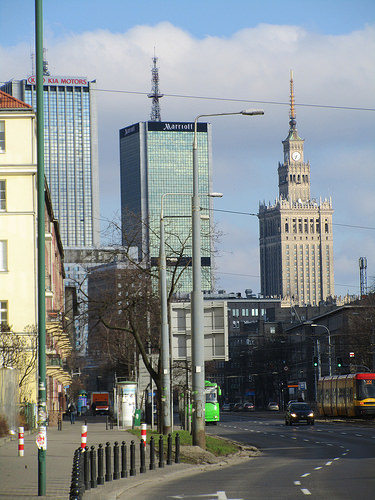<image>
Is there a building in front of the bus? No. The building is not in front of the bus. The spatial positioning shows a different relationship between these objects. 